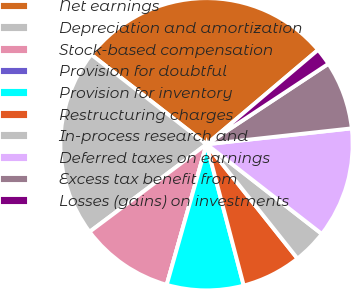Convert chart to OTSL. <chart><loc_0><loc_0><loc_500><loc_500><pie_chart><fcel>Net earnings<fcel>Depreciation and amortization<fcel>Stock-based compensation<fcel>Provision for doubtful<fcel>Provision for inventory<fcel>Restructuring charges<fcel>In-process research and<fcel>Deferred taxes on earnings<fcel>Excess tax benefit from<fcel>Losses (gains) on investments<nl><fcel>28.3%<fcel>20.75%<fcel>10.38%<fcel>0.0%<fcel>8.49%<fcel>6.6%<fcel>3.78%<fcel>12.26%<fcel>7.55%<fcel>1.89%<nl></chart> 